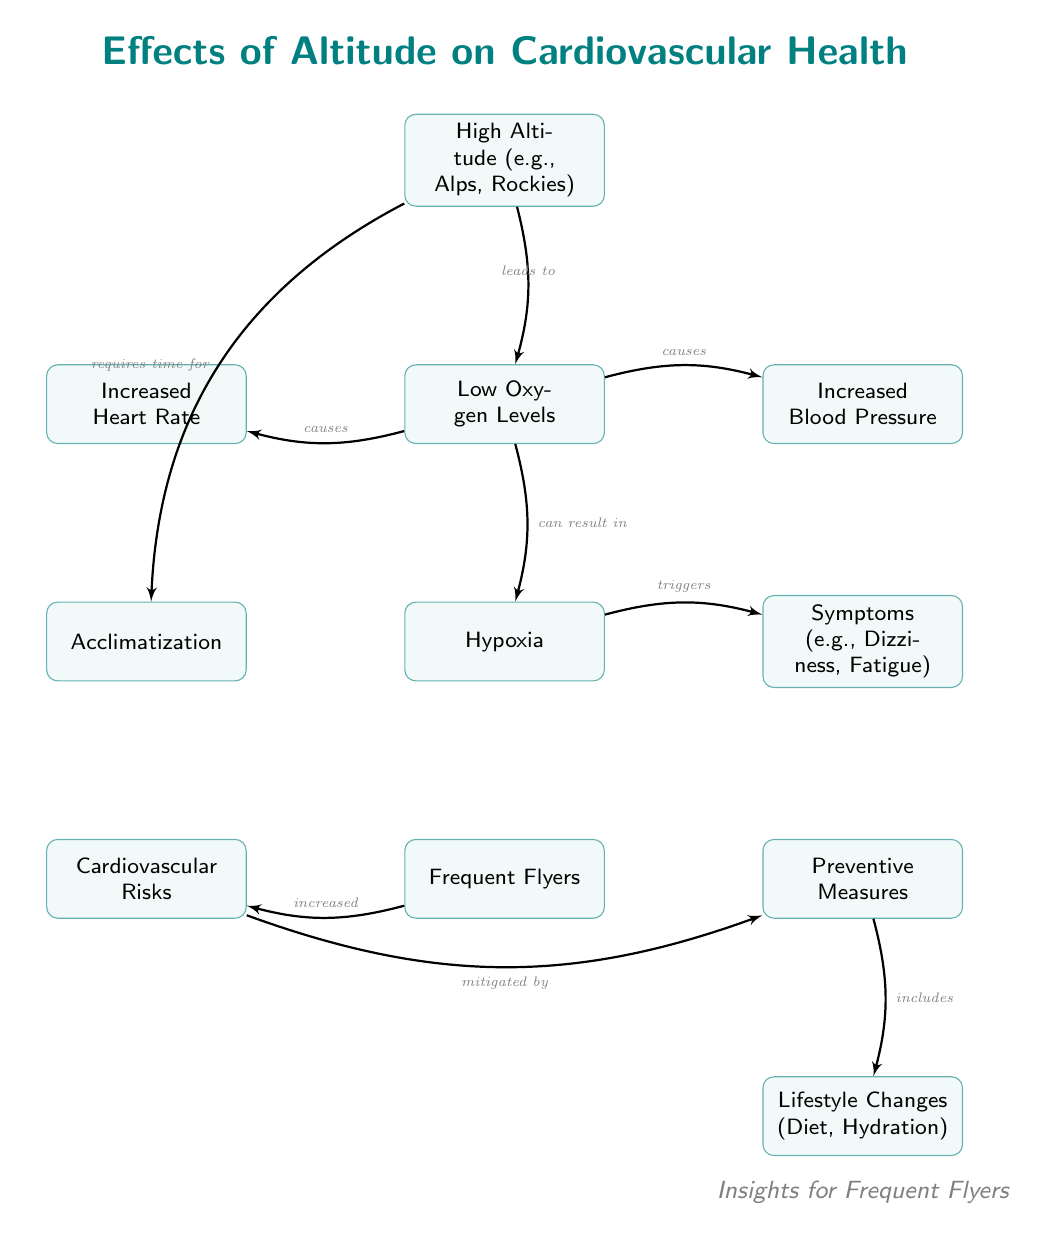What does high altitude lead to? The diagram shows that high altitude leads to low oxygen levels, indicated by the directed edge from the node "High Altitude (e.g., Alps, Rockies)" to the node "Low Oxygen Levels."
Answer: Low Oxygen Levels What are the symptoms of hypoxia? According to the diagram, symptoms of hypoxia include dizziness and fatigue, as denoted in the node "Symptoms (e.g., Dizziness, Fatigue)" connected to the hypoxia node.
Answer: Dizziness, Fatigue What does low oxygen levels cause? The diagram reveals that low oxygen levels can cause increased heart rate and increased blood pressure, as two separate edges lead from "Low Oxygen Levels" to the corresponding nodes "Increased Heart Rate" and "Increased Blood Pressure."
Answer: Increased Heart Rate, Increased Blood Pressure Which node is triggered by hypoxia? The diagram indicates that the node "Symptoms (e.g., Dizziness, Fatigue)" is triggered by hypoxia, as there is an edge pointing from "Hypoxia" to "Symptoms."
Answer: Symptoms (e.g., Dizziness, Fatigue) How does acclimatization relate to high altitude? The diagram shows that acclimatization requires time when at high altitude, represented by the edge connecting "High Altitude" to "Acclimatization." This indicates a necessary adaptation process in response to the conditions of high altitude.
Answer: Requires time for What factors increase the cardiovascular risks for frequent flyers? The diagram displays a direct relationship with an edge leading from "Frequent Flyers" to "Cardiovascular Risks," indicating that being a frequent flyer is associated with increased cardiovascular risks.
Answer: Increased How can cardiovascular risks be mitigated? The diagram informs us that cardiovascular risks can be mitigated by preventive measures, with the edge from "Cardiovascular Risks" pointing to "Preventive Measures." This suggests that certain actions can counteract risks associated with altitude exposure.
Answer: Preventive Measures What includes lifestyle changes? The diagram shows that lifestyle changes encompass diet and hydration, as indicated by the node "Lifestyle Changes (Diet, Hydration)" which is linked to the "Preventive Measures" node.
Answer: Diet, Hydration What results from hypoxia? The diagram indicates that hypoxia can result in symptoms such as dizziness and fatigue, shown by the edge connecting "Hypoxia" to "Symptoms." This means that experiencing hypoxia typically leads to these symptoms.
Answer: Symptoms (e.g., Dizziness, Fatigue) 